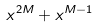<formula> <loc_0><loc_0><loc_500><loc_500>x ^ { 2 M } + x ^ { M - 1 }</formula> 